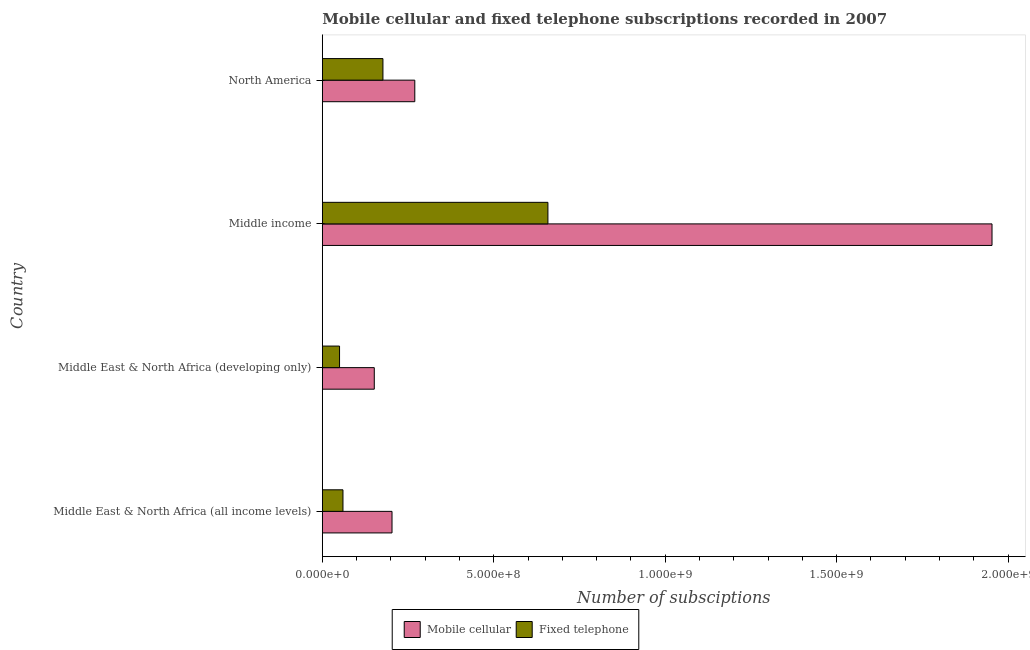How many different coloured bars are there?
Your answer should be compact. 2. How many groups of bars are there?
Offer a very short reply. 4. Are the number of bars per tick equal to the number of legend labels?
Offer a terse response. Yes. How many bars are there on the 2nd tick from the bottom?
Your response must be concise. 2. What is the label of the 4th group of bars from the top?
Offer a very short reply. Middle East & North Africa (all income levels). In how many cases, is the number of bars for a given country not equal to the number of legend labels?
Offer a very short reply. 0. What is the number of mobile cellular subscriptions in Middle income?
Your answer should be very brief. 1.95e+09. Across all countries, what is the maximum number of fixed telephone subscriptions?
Make the answer very short. 6.58e+08. Across all countries, what is the minimum number of mobile cellular subscriptions?
Ensure brevity in your answer.  1.52e+08. In which country was the number of mobile cellular subscriptions minimum?
Provide a succinct answer. Middle East & North Africa (developing only). What is the total number of fixed telephone subscriptions in the graph?
Keep it short and to the point. 9.45e+08. What is the difference between the number of fixed telephone subscriptions in Middle East & North Africa (all income levels) and that in Middle income?
Your answer should be very brief. -5.98e+08. What is the difference between the number of fixed telephone subscriptions in Middle East & North Africa (all income levels) and the number of mobile cellular subscriptions in Middle East & North Africa (developing only)?
Offer a very short reply. -9.13e+07. What is the average number of mobile cellular subscriptions per country?
Give a very brief answer. 6.44e+08. What is the difference between the number of mobile cellular subscriptions and number of fixed telephone subscriptions in Middle income?
Your answer should be compact. 1.30e+09. In how many countries, is the number of mobile cellular subscriptions greater than 400000000 ?
Your response must be concise. 1. What is the ratio of the number of fixed telephone subscriptions in Middle East & North Africa (all income levels) to that in Middle income?
Your answer should be compact. 0.09. Is the number of fixed telephone subscriptions in Middle East & North Africa (all income levels) less than that in Middle East & North Africa (developing only)?
Provide a short and direct response. No. Is the difference between the number of fixed telephone subscriptions in Middle income and North America greater than the difference between the number of mobile cellular subscriptions in Middle income and North America?
Offer a very short reply. No. What is the difference between the highest and the second highest number of mobile cellular subscriptions?
Give a very brief answer. 1.68e+09. What is the difference between the highest and the lowest number of mobile cellular subscriptions?
Offer a very short reply. 1.80e+09. In how many countries, is the number of fixed telephone subscriptions greater than the average number of fixed telephone subscriptions taken over all countries?
Keep it short and to the point. 1. What does the 2nd bar from the top in Middle income represents?
Provide a succinct answer. Mobile cellular. What does the 2nd bar from the bottom in North America represents?
Provide a succinct answer. Fixed telephone. Are all the bars in the graph horizontal?
Your answer should be very brief. Yes. How many countries are there in the graph?
Provide a succinct answer. 4. What is the difference between two consecutive major ticks on the X-axis?
Make the answer very short. 5.00e+08. Does the graph contain grids?
Keep it short and to the point. No. Where does the legend appear in the graph?
Provide a succinct answer. Bottom center. How many legend labels are there?
Offer a terse response. 2. What is the title of the graph?
Your response must be concise. Mobile cellular and fixed telephone subscriptions recorded in 2007. What is the label or title of the X-axis?
Offer a terse response. Number of subsciptions. What is the Number of subsciptions of Mobile cellular in Middle East & North Africa (all income levels)?
Your answer should be compact. 2.03e+08. What is the Number of subsciptions in Fixed telephone in Middle East & North Africa (all income levels)?
Keep it short and to the point. 6.02e+07. What is the Number of subsciptions in Mobile cellular in Middle East & North Africa (developing only)?
Ensure brevity in your answer.  1.52e+08. What is the Number of subsciptions in Fixed telephone in Middle East & North Africa (developing only)?
Provide a short and direct response. 5.02e+07. What is the Number of subsciptions in Mobile cellular in Middle income?
Give a very brief answer. 1.95e+09. What is the Number of subsciptions in Fixed telephone in Middle income?
Offer a terse response. 6.58e+08. What is the Number of subsciptions of Mobile cellular in North America?
Provide a short and direct response. 2.70e+08. What is the Number of subsciptions of Fixed telephone in North America?
Offer a very short reply. 1.77e+08. Across all countries, what is the maximum Number of subsciptions of Mobile cellular?
Give a very brief answer. 1.95e+09. Across all countries, what is the maximum Number of subsciptions of Fixed telephone?
Ensure brevity in your answer.  6.58e+08. Across all countries, what is the minimum Number of subsciptions in Mobile cellular?
Provide a succinct answer. 1.52e+08. Across all countries, what is the minimum Number of subsciptions in Fixed telephone?
Your response must be concise. 5.02e+07. What is the total Number of subsciptions in Mobile cellular in the graph?
Keep it short and to the point. 2.58e+09. What is the total Number of subsciptions in Fixed telephone in the graph?
Provide a short and direct response. 9.45e+08. What is the difference between the Number of subsciptions in Mobile cellular in Middle East & North Africa (all income levels) and that in Middle East & North Africa (developing only)?
Give a very brief answer. 5.17e+07. What is the difference between the Number of subsciptions in Fixed telephone in Middle East & North Africa (all income levels) and that in Middle East & North Africa (developing only)?
Give a very brief answer. 9.96e+06. What is the difference between the Number of subsciptions of Mobile cellular in Middle East & North Africa (all income levels) and that in Middle income?
Keep it short and to the point. -1.75e+09. What is the difference between the Number of subsciptions in Fixed telephone in Middle East & North Africa (all income levels) and that in Middle income?
Keep it short and to the point. -5.98e+08. What is the difference between the Number of subsciptions of Mobile cellular in Middle East & North Africa (all income levels) and that in North America?
Offer a very short reply. -6.64e+07. What is the difference between the Number of subsciptions of Fixed telephone in Middle East & North Africa (all income levels) and that in North America?
Offer a terse response. -1.17e+08. What is the difference between the Number of subsciptions in Mobile cellular in Middle East & North Africa (developing only) and that in Middle income?
Ensure brevity in your answer.  -1.80e+09. What is the difference between the Number of subsciptions of Fixed telephone in Middle East & North Africa (developing only) and that in Middle income?
Your answer should be compact. -6.08e+08. What is the difference between the Number of subsciptions of Mobile cellular in Middle East & North Africa (developing only) and that in North America?
Offer a terse response. -1.18e+08. What is the difference between the Number of subsciptions in Fixed telephone in Middle East & North Africa (developing only) and that in North America?
Give a very brief answer. -1.27e+08. What is the difference between the Number of subsciptions of Mobile cellular in Middle income and that in North America?
Your response must be concise. 1.68e+09. What is the difference between the Number of subsciptions in Fixed telephone in Middle income and that in North America?
Ensure brevity in your answer.  4.81e+08. What is the difference between the Number of subsciptions in Mobile cellular in Middle East & North Africa (all income levels) and the Number of subsciptions in Fixed telephone in Middle East & North Africa (developing only)?
Your response must be concise. 1.53e+08. What is the difference between the Number of subsciptions of Mobile cellular in Middle East & North Africa (all income levels) and the Number of subsciptions of Fixed telephone in Middle income?
Ensure brevity in your answer.  -4.55e+08. What is the difference between the Number of subsciptions in Mobile cellular in Middle East & North Africa (all income levels) and the Number of subsciptions in Fixed telephone in North America?
Ensure brevity in your answer.  2.65e+07. What is the difference between the Number of subsciptions of Mobile cellular in Middle East & North Africa (developing only) and the Number of subsciptions of Fixed telephone in Middle income?
Give a very brief answer. -5.06e+08. What is the difference between the Number of subsciptions of Mobile cellular in Middle East & North Africa (developing only) and the Number of subsciptions of Fixed telephone in North America?
Provide a succinct answer. -2.52e+07. What is the difference between the Number of subsciptions of Mobile cellular in Middle income and the Number of subsciptions of Fixed telephone in North America?
Offer a very short reply. 1.78e+09. What is the average Number of subsciptions of Mobile cellular per country?
Make the answer very short. 6.44e+08. What is the average Number of subsciptions of Fixed telephone per country?
Keep it short and to the point. 2.36e+08. What is the difference between the Number of subsciptions in Mobile cellular and Number of subsciptions in Fixed telephone in Middle East & North Africa (all income levels)?
Offer a very short reply. 1.43e+08. What is the difference between the Number of subsciptions of Mobile cellular and Number of subsciptions of Fixed telephone in Middle East & North Africa (developing only)?
Make the answer very short. 1.01e+08. What is the difference between the Number of subsciptions of Mobile cellular and Number of subsciptions of Fixed telephone in Middle income?
Your answer should be very brief. 1.30e+09. What is the difference between the Number of subsciptions in Mobile cellular and Number of subsciptions in Fixed telephone in North America?
Keep it short and to the point. 9.29e+07. What is the ratio of the Number of subsciptions of Mobile cellular in Middle East & North Africa (all income levels) to that in Middle East & North Africa (developing only)?
Ensure brevity in your answer.  1.34. What is the ratio of the Number of subsciptions in Fixed telephone in Middle East & North Africa (all income levels) to that in Middle East & North Africa (developing only)?
Offer a terse response. 1.2. What is the ratio of the Number of subsciptions in Mobile cellular in Middle East & North Africa (all income levels) to that in Middle income?
Make the answer very short. 0.1. What is the ratio of the Number of subsciptions in Fixed telephone in Middle East & North Africa (all income levels) to that in Middle income?
Offer a very short reply. 0.09. What is the ratio of the Number of subsciptions of Mobile cellular in Middle East & North Africa (all income levels) to that in North America?
Make the answer very short. 0.75. What is the ratio of the Number of subsciptions in Fixed telephone in Middle East & North Africa (all income levels) to that in North America?
Your response must be concise. 0.34. What is the ratio of the Number of subsciptions of Mobile cellular in Middle East & North Africa (developing only) to that in Middle income?
Offer a very short reply. 0.08. What is the ratio of the Number of subsciptions in Fixed telephone in Middle East & North Africa (developing only) to that in Middle income?
Your response must be concise. 0.08. What is the ratio of the Number of subsciptions of Mobile cellular in Middle East & North Africa (developing only) to that in North America?
Provide a succinct answer. 0.56. What is the ratio of the Number of subsciptions in Fixed telephone in Middle East & North Africa (developing only) to that in North America?
Your answer should be compact. 0.28. What is the ratio of the Number of subsciptions of Mobile cellular in Middle income to that in North America?
Offer a very short reply. 7.24. What is the ratio of the Number of subsciptions in Fixed telephone in Middle income to that in North America?
Offer a very short reply. 3.72. What is the difference between the highest and the second highest Number of subsciptions in Mobile cellular?
Your response must be concise. 1.68e+09. What is the difference between the highest and the second highest Number of subsciptions of Fixed telephone?
Your answer should be very brief. 4.81e+08. What is the difference between the highest and the lowest Number of subsciptions in Mobile cellular?
Offer a very short reply. 1.80e+09. What is the difference between the highest and the lowest Number of subsciptions of Fixed telephone?
Offer a terse response. 6.08e+08. 